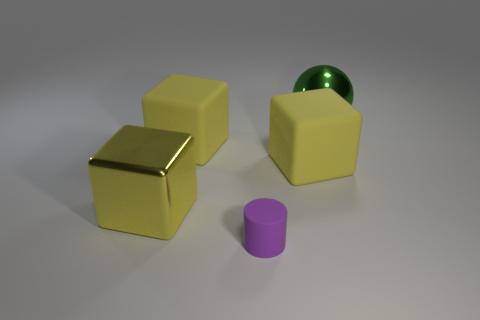What number of other blocks have the same color as the large metallic block?
Offer a terse response. 2. There is a metal object that is in front of the metallic ball behind the small thing; are there any purple objects on the right side of it?
Keep it short and to the point. Yes. The green thing that is the same size as the yellow metal block is what shape?
Ensure brevity in your answer.  Sphere. How many small objects are purple cylinders or brown metal cylinders?
Offer a terse response. 1. There is a big thing that is the same material as the sphere; what color is it?
Your answer should be compact. Yellow. There is a yellow matte object that is right of the matte cylinder; does it have the same shape as the big yellow matte object that is to the left of the cylinder?
Provide a short and direct response. Yes. What number of metal things are either big blocks or spheres?
Ensure brevity in your answer.  2. Are there any other things that have the same shape as the tiny purple matte object?
Make the answer very short. No. What is the yellow thing to the right of the small purple rubber cylinder made of?
Give a very brief answer. Rubber. Do the thing that is in front of the large yellow shiny object and the green ball have the same material?
Provide a short and direct response. No. 